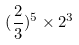Convert formula to latex. <formula><loc_0><loc_0><loc_500><loc_500>( \frac { 2 } { 3 } ) ^ { 5 } \times 2 ^ { 3 }</formula> 